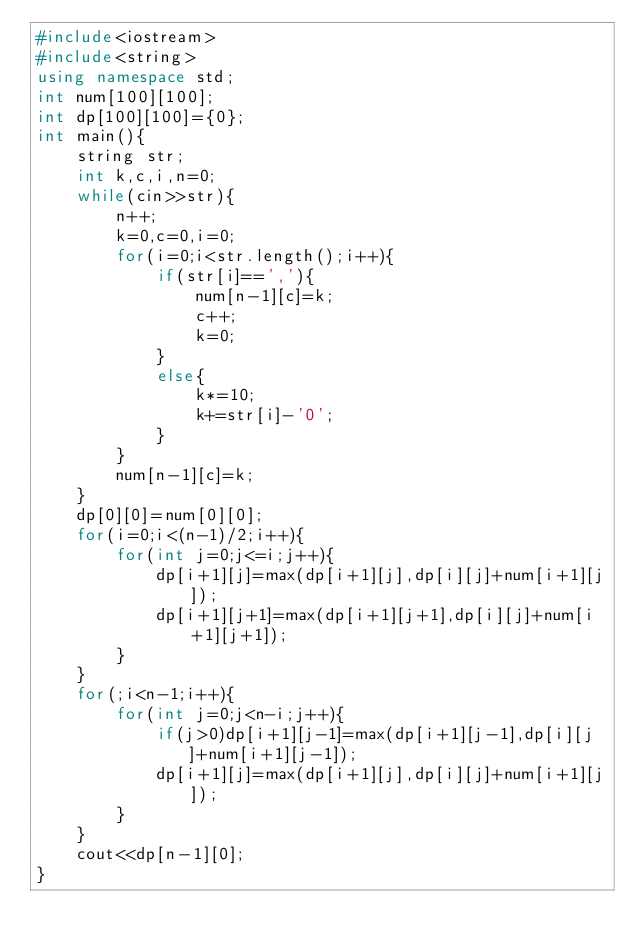Convert code to text. <code><loc_0><loc_0><loc_500><loc_500><_C++_>#include<iostream>
#include<string>
using namespace std;
int num[100][100];
int dp[100][100]={0};
int main(){
    string str;
    int k,c,i,n=0;
    while(cin>>str){
        n++;
        k=0,c=0,i=0;
        for(i=0;i<str.length();i++){
            if(str[i]==','){
                num[n-1][c]=k;
                c++;
                k=0;
            }
            else{
                k*=10;
                k+=str[i]-'0';
            }
        }
        num[n-1][c]=k;
    }
    dp[0][0]=num[0][0];
    for(i=0;i<(n-1)/2;i++){
        for(int j=0;j<=i;j++){
            dp[i+1][j]=max(dp[i+1][j],dp[i][j]+num[i+1][j]);
            dp[i+1][j+1]=max(dp[i+1][j+1],dp[i][j]+num[i+1][j+1]);
        }
    }
    for(;i<n-1;i++){
        for(int j=0;j<n-i;j++){
            if(j>0)dp[i+1][j-1]=max(dp[i+1][j-1],dp[i][j]+num[i+1][j-1]);
            dp[i+1][j]=max(dp[i+1][j],dp[i][j]+num[i+1][j]);
        }
    }
    cout<<dp[n-1][0];
}</code> 